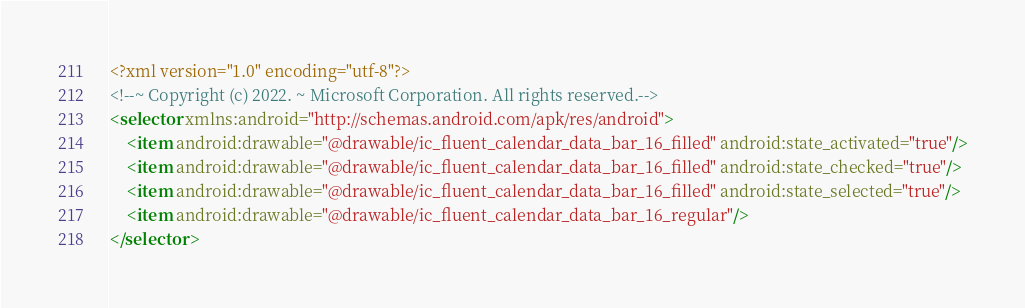Convert code to text. <code><loc_0><loc_0><loc_500><loc_500><_XML_><?xml version="1.0" encoding="utf-8"?>
<!--~ Copyright (c) 2022. ~ Microsoft Corporation. All rights reserved.-->
<selector xmlns:android="http://schemas.android.com/apk/res/android">
    <item android:drawable="@drawable/ic_fluent_calendar_data_bar_16_filled" android:state_activated="true"/>
    <item android:drawable="@drawable/ic_fluent_calendar_data_bar_16_filled" android:state_checked="true"/>
    <item android:drawable="@drawable/ic_fluent_calendar_data_bar_16_filled" android:state_selected="true"/>
    <item android:drawable="@drawable/ic_fluent_calendar_data_bar_16_regular"/>
</selector>
</code> 